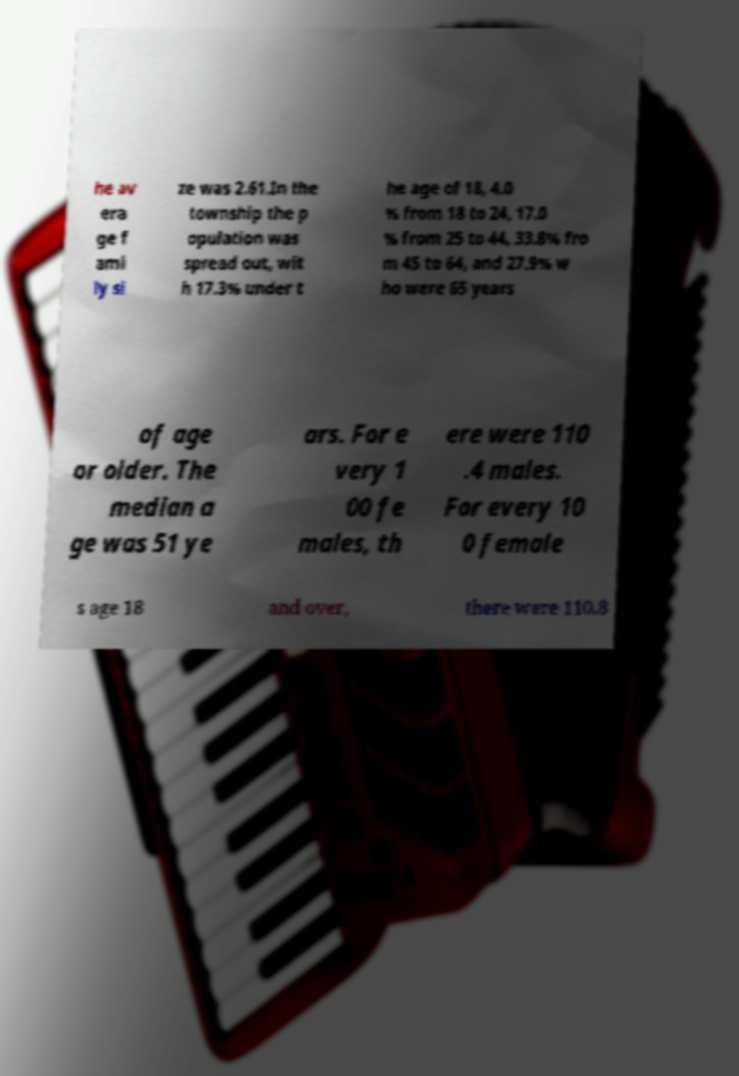Please identify and transcribe the text found in this image. he av era ge f ami ly si ze was 2.61.In the township the p opulation was spread out, wit h 17.3% under t he age of 18, 4.0 % from 18 to 24, 17.0 % from 25 to 44, 33.8% fro m 45 to 64, and 27.9% w ho were 65 years of age or older. The median a ge was 51 ye ars. For e very 1 00 fe males, th ere were 110 .4 males. For every 10 0 female s age 18 and over, there were 110.8 